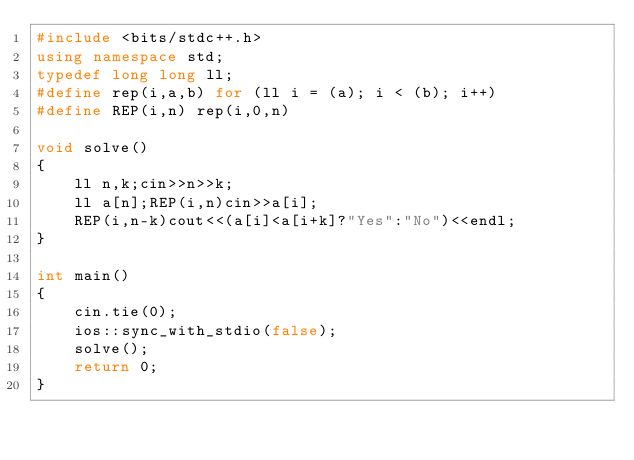Convert code to text. <code><loc_0><loc_0><loc_500><loc_500><_C++_>#include <bits/stdc++.h>
using namespace std;
typedef long long ll;
#define rep(i,a,b) for (ll i = (a); i < (b); i++)
#define REP(i,n) rep(i,0,n)

void solve() 
{
    ll n,k;cin>>n>>k;
    ll a[n];REP(i,n)cin>>a[i];
    REP(i,n-k)cout<<(a[i]<a[i+k]?"Yes":"No")<<endl;
}

int main()
{
    cin.tie(0);
	ios::sync_with_stdio(false);
    solve();
    return 0;
}</code> 